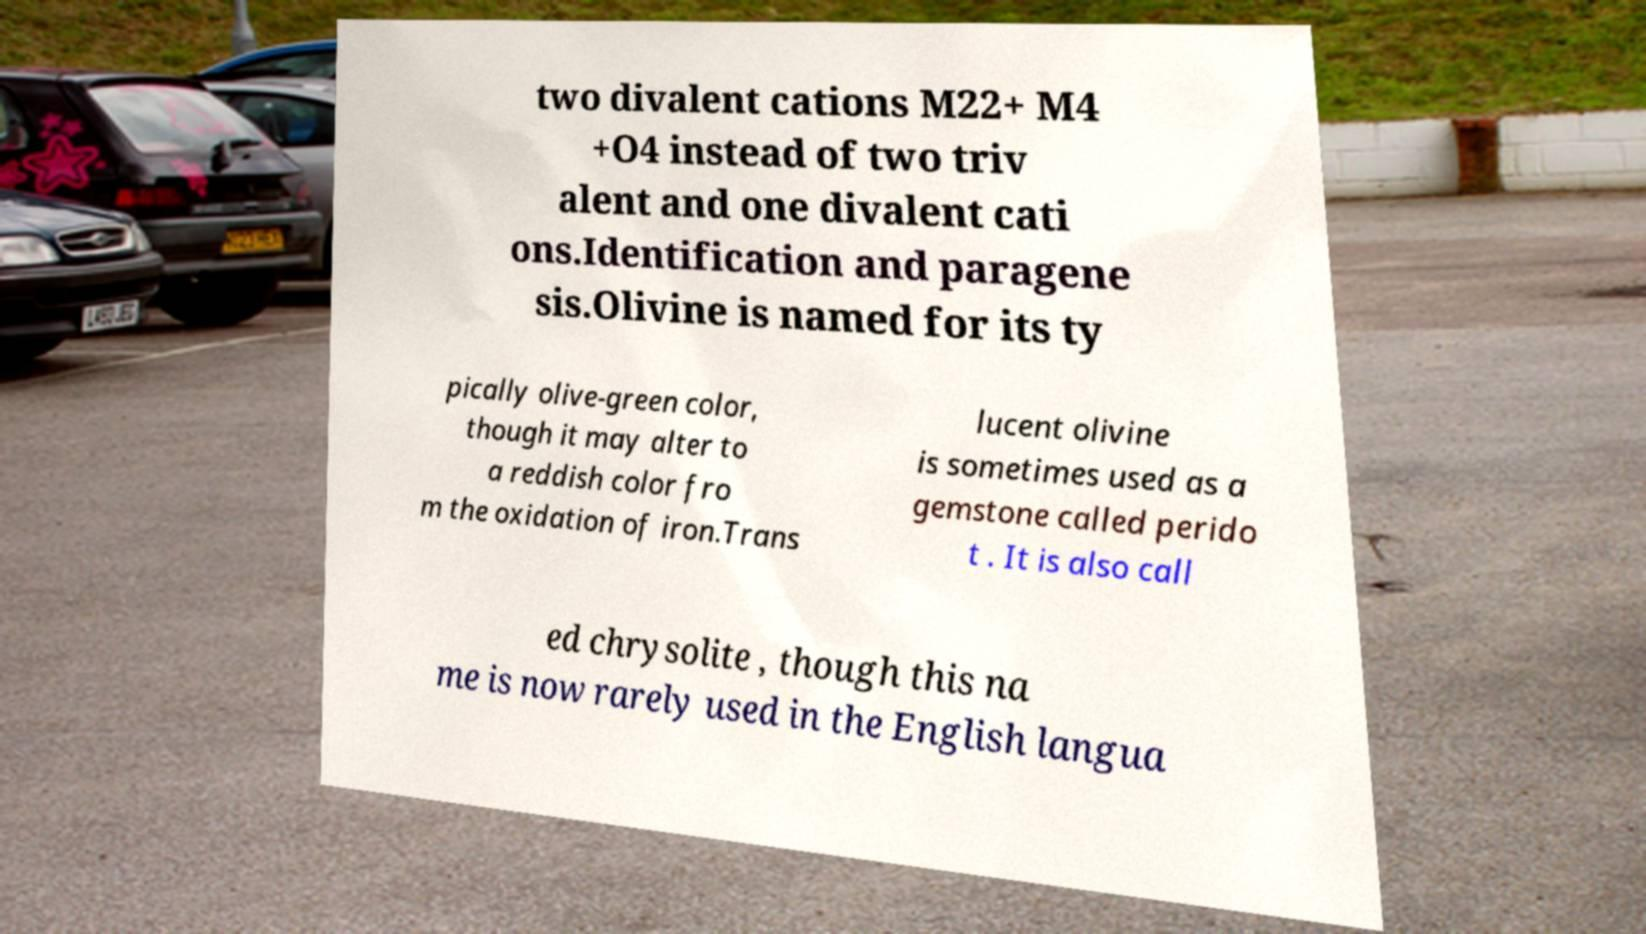Can you accurately transcribe the text from the provided image for me? two divalent cations M22+ M4 +O4 instead of two triv alent and one divalent cati ons.Identification and paragene sis.Olivine is named for its ty pically olive-green color, though it may alter to a reddish color fro m the oxidation of iron.Trans lucent olivine is sometimes used as a gemstone called perido t . It is also call ed chrysolite , though this na me is now rarely used in the English langua 